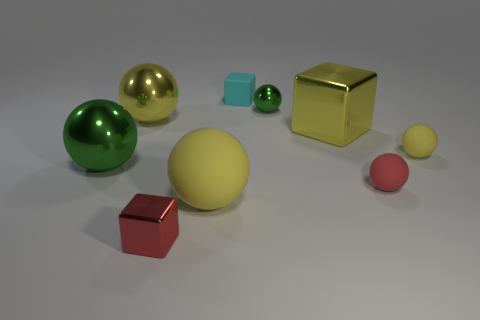How many yellow balls must be subtracted to get 1 yellow balls? 2 Subtract all blue blocks. How many yellow balls are left? 3 Subtract all yellow metallic spheres. How many spheres are left? 5 Subtract all red balls. How many balls are left? 5 Subtract all red spheres. Subtract all yellow cylinders. How many spheres are left? 5 Add 1 small blocks. How many objects exist? 10 Subtract all cubes. How many objects are left? 6 Add 4 tiny red spheres. How many tiny red spheres exist? 5 Subtract 0 green cylinders. How many objects are left? 9 Subtract all tiny green shiny objects. Subtract all shiny balls. How many objects are left? 5 